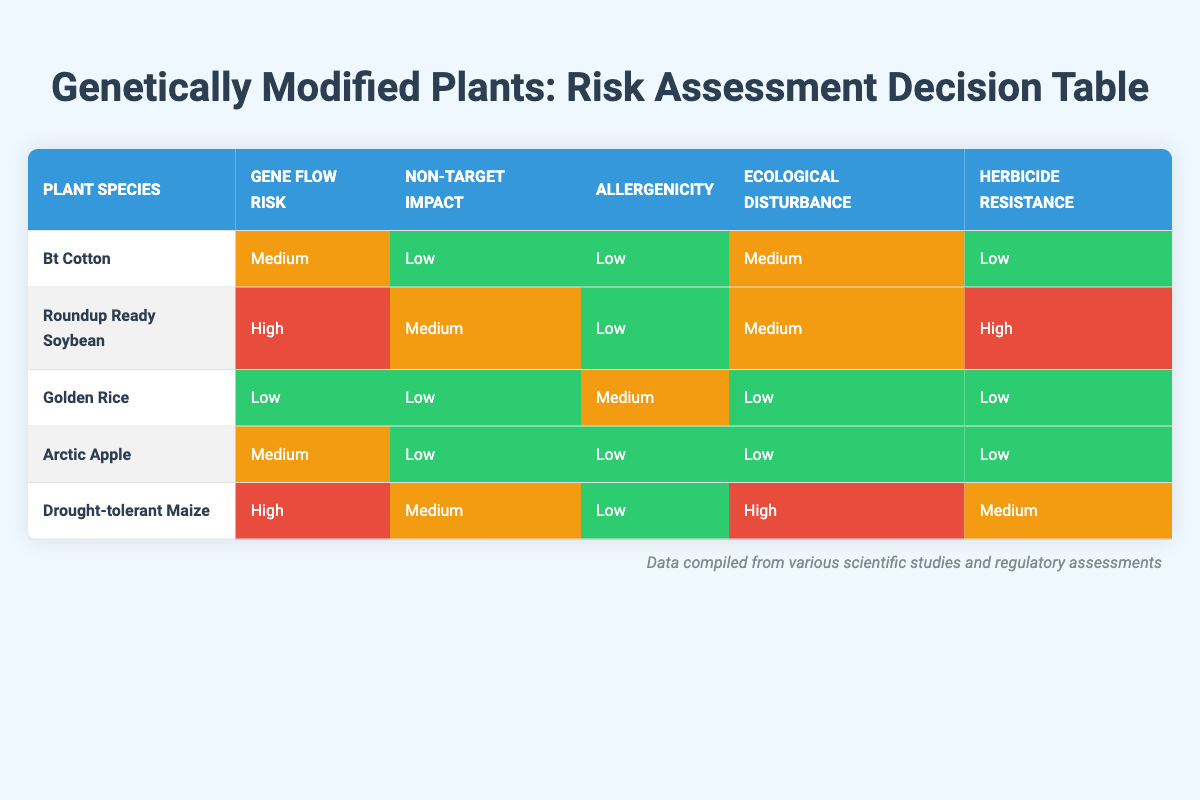What is the gene flow risk associated with Golden Rice? According to the table, Golden Rice has a gene flow risk classified as "Low."
Answer: Low Which plant has the highest herbicide resistance transfer risk? The table indicates that Roundup Ready Soybean has a herbicide resistance transfer risk classified as "High."
Answer: Roundup Ready Soybean How many plants have a low impact on non-target organisms? By inspecting the table, Golden Rice, Bt Cotton, Arctic Apple, and Drought-tolerant Maize have "Low" categorized non-target impacts, giving a total of four plants.
Answer: 4 Does Arctic Apple have a high ecological disturbance potential? The ecological disturbance potential for Arctic Apple is marked as "Low" in the table, so it does not have a high potential.
Answer: No What is the average allergenicity risk among the listed plants? To find the average, we count allergenicity ratings: Bt Cotton (Low), Roundup Ready Soybean (Low), Golden Rice (Medium), Arctic Apple (Low), and Drought-tolerant Maize (Low). Converting these to numerical values (Low = 1, Medium = 2): (1 + 1 + 2 + 1 + 1) = 6, then divide by 5 gives an average allergenicity risk of 1.2, which is approximately Low.
Answer: Low What is the gene flow risk for Drought-tolerant Maize compared to Roundup Ready Soybean? Drought-tolerant Maize is classified as "High" while Roundup Ready Soybean is also classified as "High." Therefore, both have the same level of gene flow risk.
Answer: Same Which has a medium ecological disturbance potential, Bt Cotton or Drought-tolerant Maize? The assessment for ecological disturbance shows that Bt Cotton is rated as "Medium" while Drought-tolerant Maize is rated as "High." Hence, Bt Cotton has the medium ecological disturbance potential.
Answer: Bt Cotton Among the plants assessed, which one has the lowest overall risks across all categories? Reviewing the table, Golden Rice has all low ratings except for allergenicity, which is medium. Comparatively, other plants have higher risks in various categories, making it have the lowest overall risk.
Answer: Golden Rice 